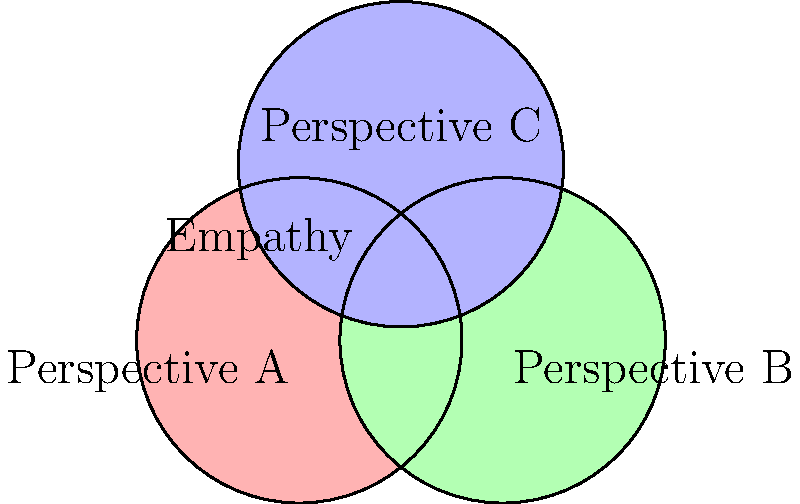In the illustration above, three overlapping circles represent different perspectives. How does this visual representation relate to the concept of empathy, and what area in the diagram best symbolizes a deep understanding of others? 1. The diagram shows three overlapping circles, each representing a different perspective (A, B, and C).

2. Empathy is the ability to understand and share the feelings of another person, putting yourself in their shoes.

3. The overlapping areas of the circles represent shared understanding or common ground between different perspectives:
   - Where two circles overlap: partial understanding between two perspectives
   - Where all three circles overlap: a deeper, more comprehensive understanding

4. The central area, where all three circles intersect, symbolizes the highest level of empathy:
   - It represents a point where all perspectives are considered and understood
   - This area suggests a person has taken the time to see things from multiple viewpoints

5. As an artist focusing on love and acceptance, this central area would be the ideal place to illustrate deep empathy:
   - It shows the ability to consider and integrate multiple perspectives
   - It represents a holistic understanding that goes beyond individual viewpoints

6. The diagram as a whole illustrates that empathy is not about losing one's own perspective (each circle maintains its individual area) but about finding common ground and understanding (the overlapping areas).
Answer: The central area where all three circles intersect 